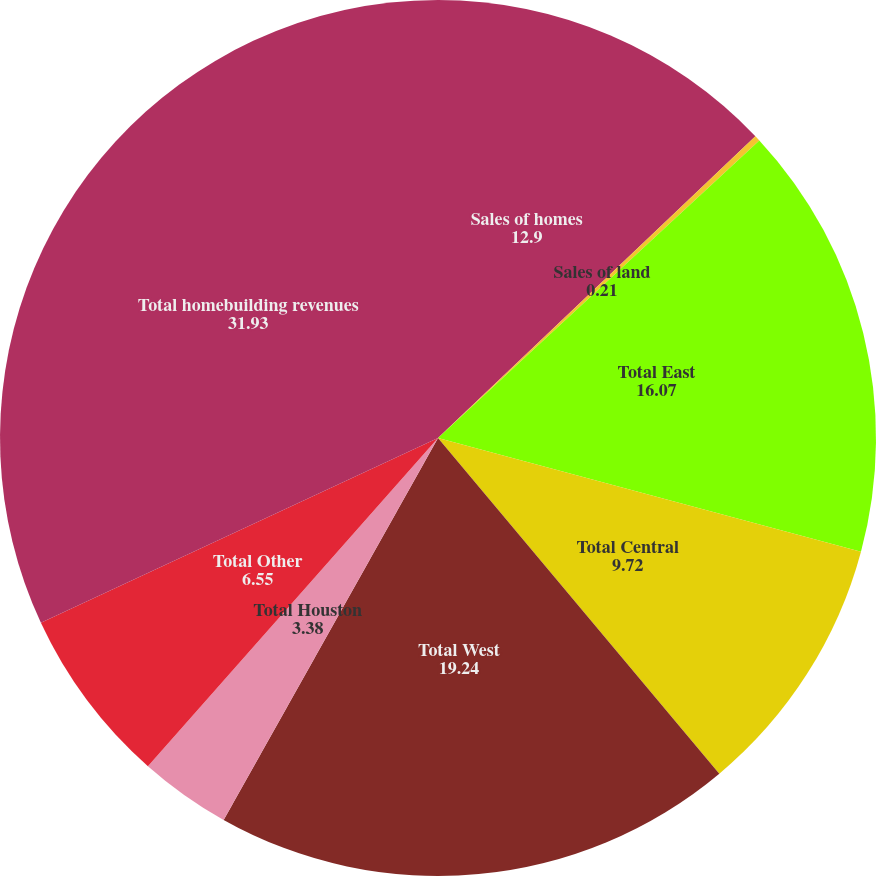Convert chart to OTSL. <chart><loc_0><loc_0><loc_500><loc_500><pie_chart><fcel>Sales of homes<fcel>Sales of land<fcel>Total East<fcel>Total Central<fcel>Total West<fcel>Total Houston<fcel>Total Other<fcel>Total homebuilding revenues<nl><fcel>12.9%<fcel>0.21%<fcel>16.07%<fcel>9.72%<fcel>19.24%<fcel>3.38%<fcel>6.55%<fcel>31.93%<nl></chart> 